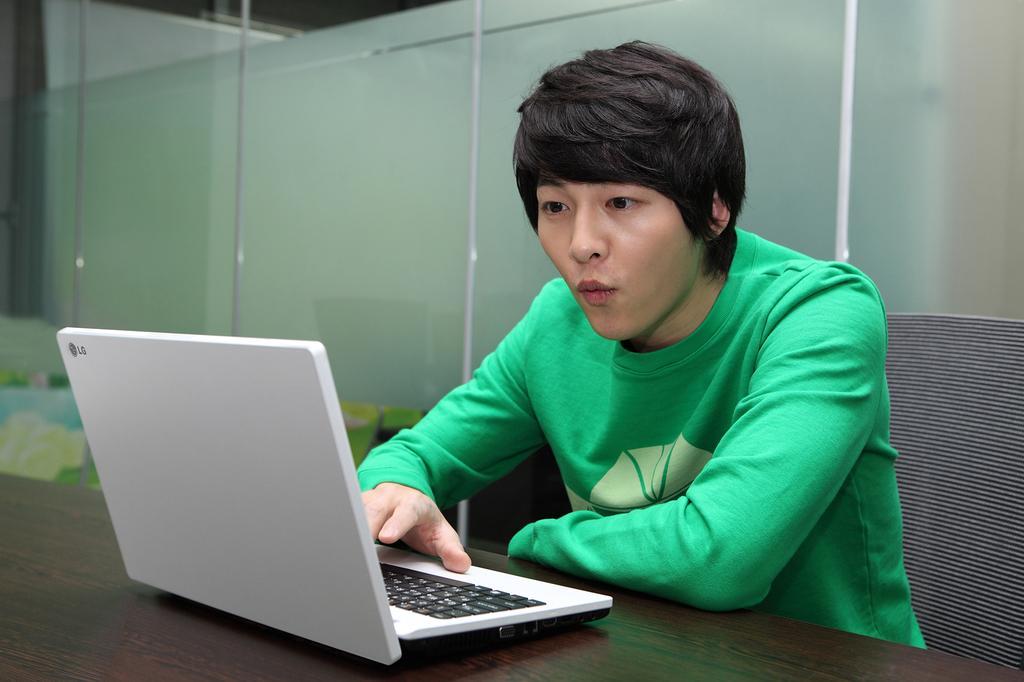In one or two sentences, can you explain what this image depicts? In the center of the image we can see a man sitting, before him there is a table and there is a laptop placed on the table. In the background there is a glass wall. 